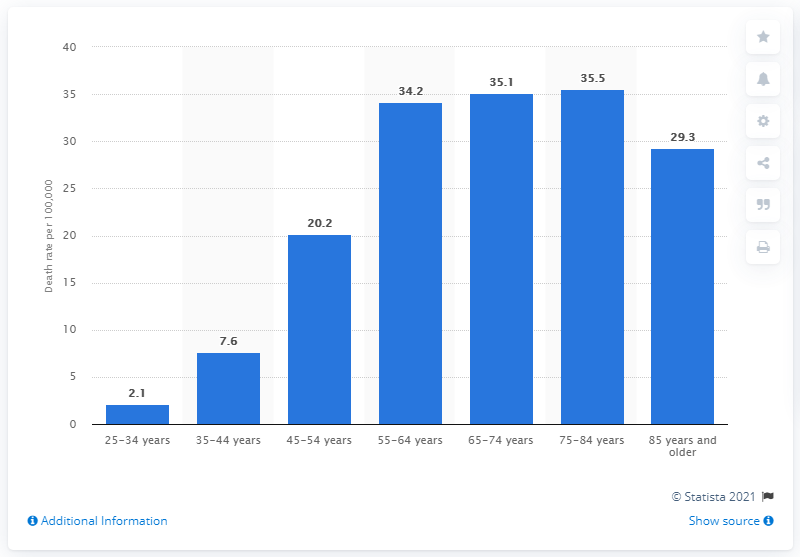Outline some significant characteristics in this image. The highest death rate from liver cirrhosis in the United States was observed in individuals aged 75 to 84 years in 2017. 